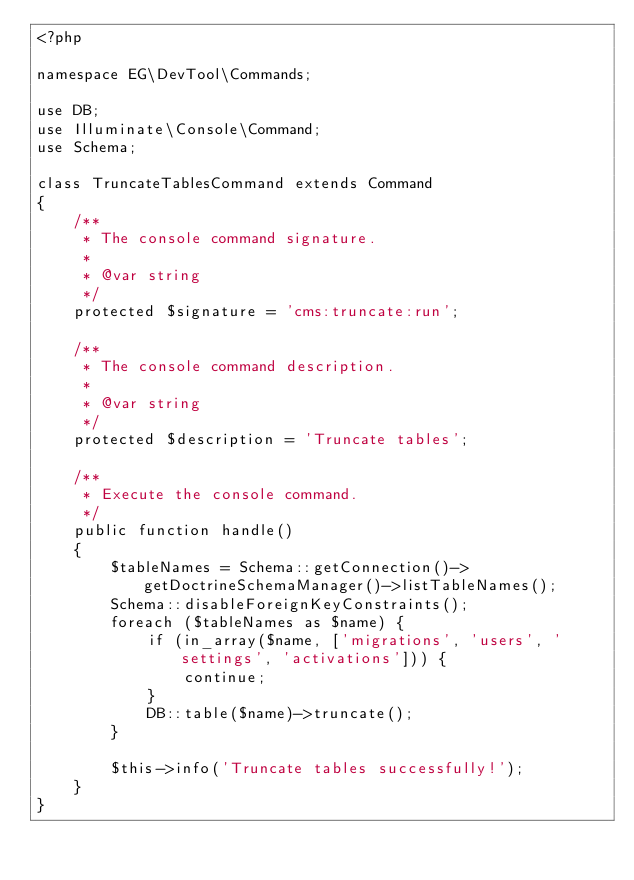Convert code to text. <code><loc_0><loc_0><loc_500><loc_500><_PHP_><?php

namespace EG\DevTool\Commands;

use DB;
use Illuminate\Console\Command;
use Schema;

class TruncateTablesCommand extends Command
{
    /**
     * The console command signature.
     *
     * @var string
     */
    protected $signature = 'cms:truncate:run';

    /**
     * The console command description.
     *
     * @var string
     */
    protected $description = 'Truncate tables';

    /**
     * Execute the console command.
     */
    public function handle()
    {
        $tableNames = Schema::getConnection()->getDoctrineSchemaManager()->listTableNames();
        Schema::disableForeignKeyConstraints();
        foreach ($tableNames as $name) {
            if (in_array($name, ['migrations', 'users', 'settings', 'activations'])) {
                continue;
            }
            DB::table($name)->truncate();
        }

        $this->info('Truncate tables successfully!');
    }
}
</code> 